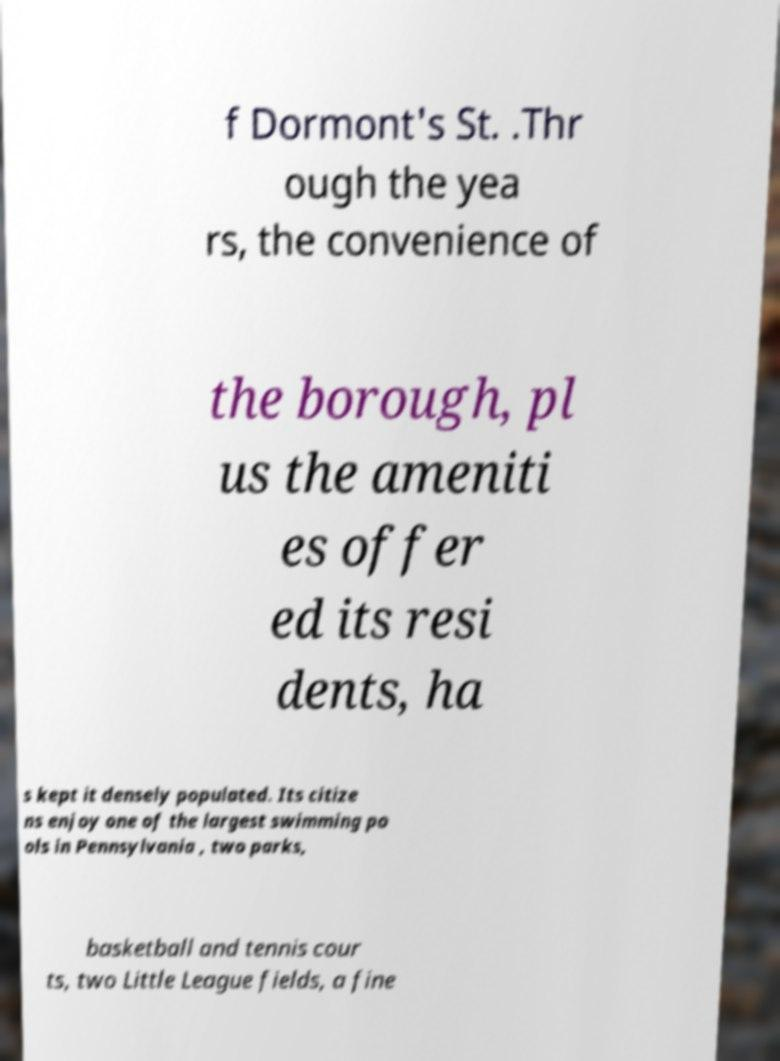Can you read and provide the text displayed in the image?This photo seems to have some interesting text. Can you extract and type it out for me? f Dormont's St. .Thr ough the yea rs, the convenience of the borough, pl us the ameniti es offer ed its resi dents, ha s kept it densely populated. Its citize ns enjoy one of the largest swimming po ols in Pennsylvania , two parks, basketball and tennis cour ts, two Little League fields, a fine 